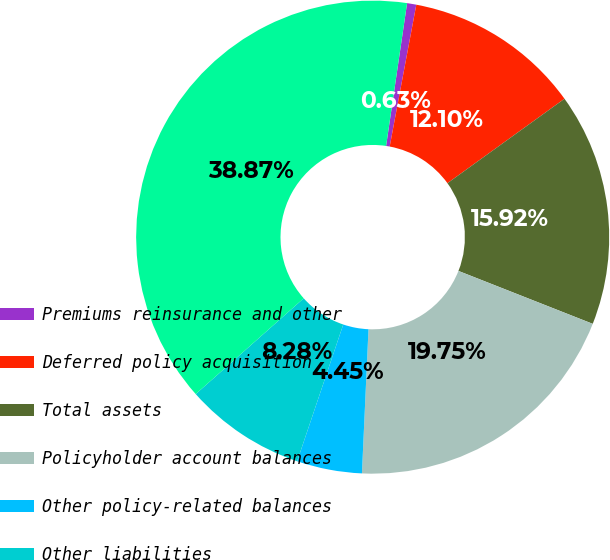Convert chart to OTSL. <chart><loc_0><loc_0><loc_500><loc_500><pie_chart><fcel>Premiums reinsurance and other<fcel>Deferred policy acquisition<fcel>Total assets<fcel>Policyholder account balances<fcel>Other policy-related balances<fcel>Other liabilities<fcel>Total liabilities<nl><fcel>0.63%<fcel>12.1%<fcel>15.92%<fcel>19.75%<fcel>4.45%<fcel>8.28%<fcel>38.87%<nl></chart> 